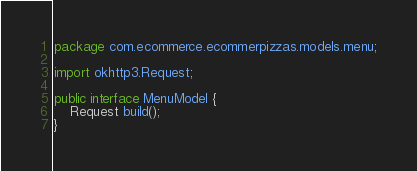Convert code to text. <code><loc_0><loc_0><loc_500><loc_500><_Java_>package com.ecommerce.ecommerpizzas.models.menu;

import okhttp3.Request;

public interface MenuModel {
    Request build();
}
</code> 